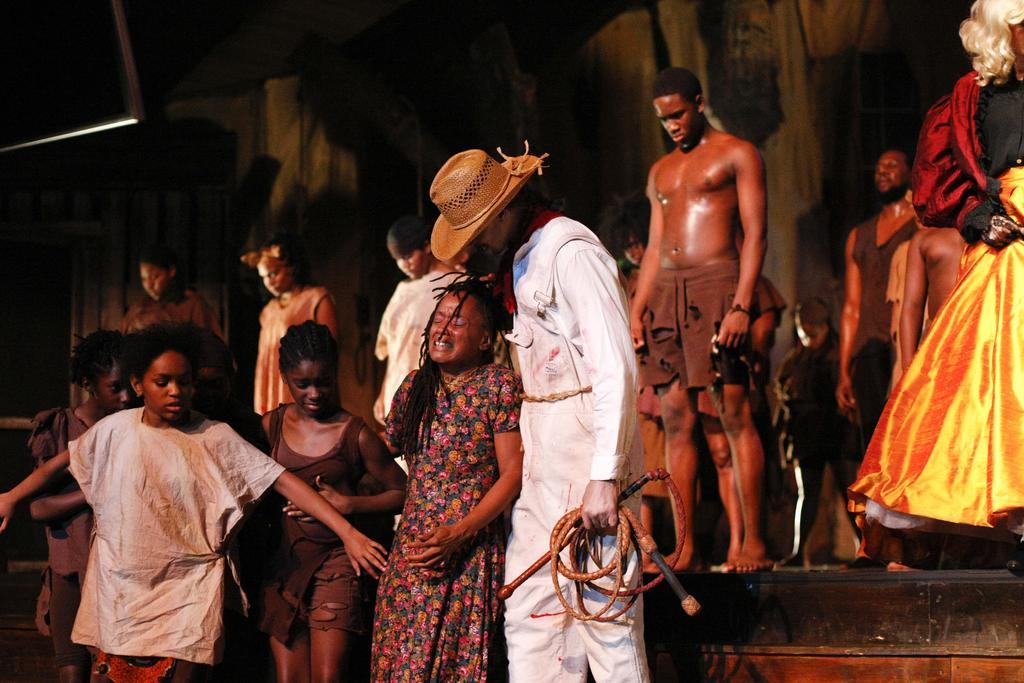Describe this image in one or two sentences. This is looking like a drama is going on. On the stage there are many people. In the middle one man wearing hat , white dress is holding a rope. Beside him a lady is crying. In the background there curtain. 